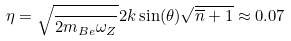Convert formula to latex. <formula><loc_0><loc_0><loc_500><loc_500>\eta = \sqrt { \frac { } { 2 m _ { B e } \omega _ { Z } } } 2 k \sin ( \theta ) \sqrt { \overline { n } + 1 } \approx 0 . 0 7</formula> 